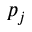<formula> <loc_0><loc_0><loc_500><loc_500>p _ { j }</formula> 